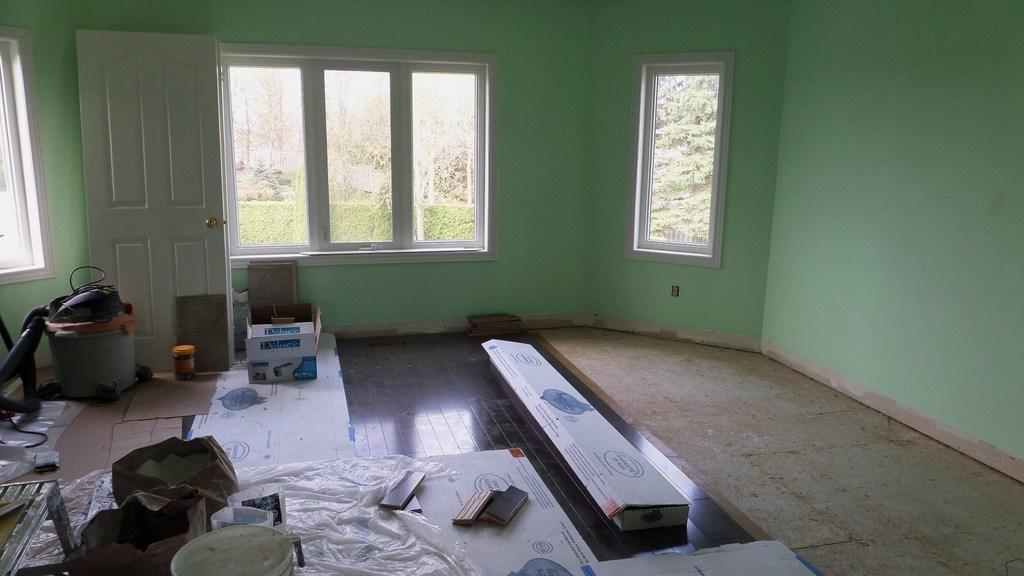Where was the image taken? The image was taken inside a room. What objects can be seen in the room? There are cardboard boxes, a basket, a bag, a table, containers, covers, and a door in the room. What part of the room is visible? The floor, wall, and windows are visible in the room. What type of insect is crawling on the suit in the image? There is no suit or insect present in the image. 